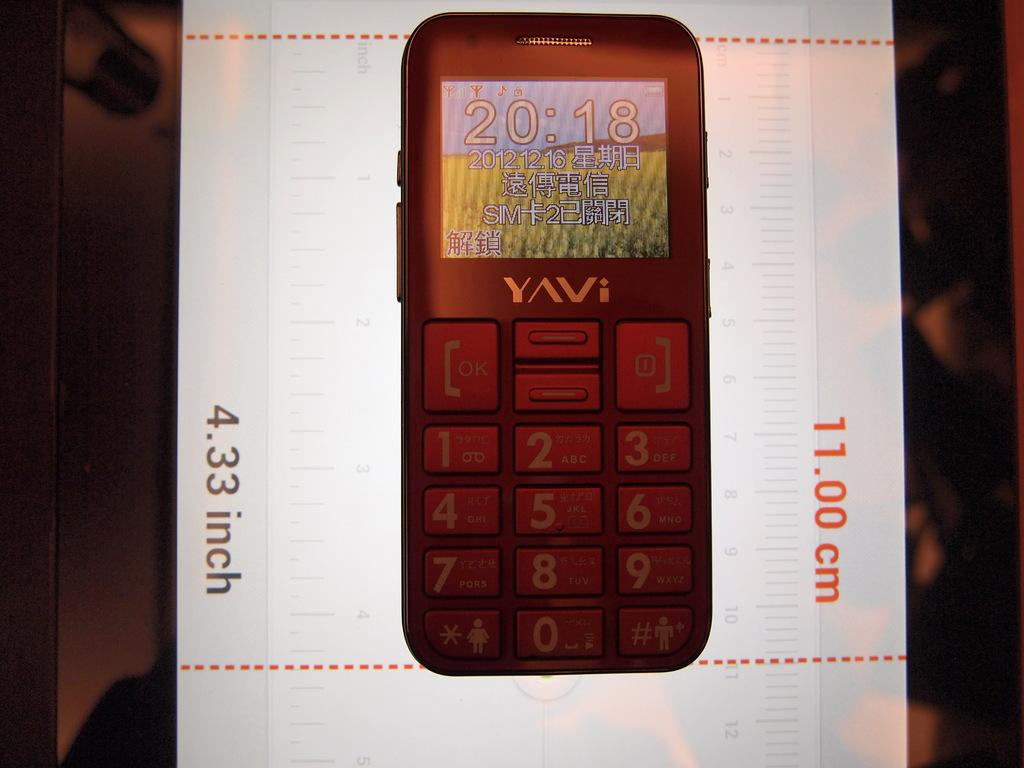<image>
Summarize the visual content of the image. A box for a Yavi phone says that it is 11 centimeters. 